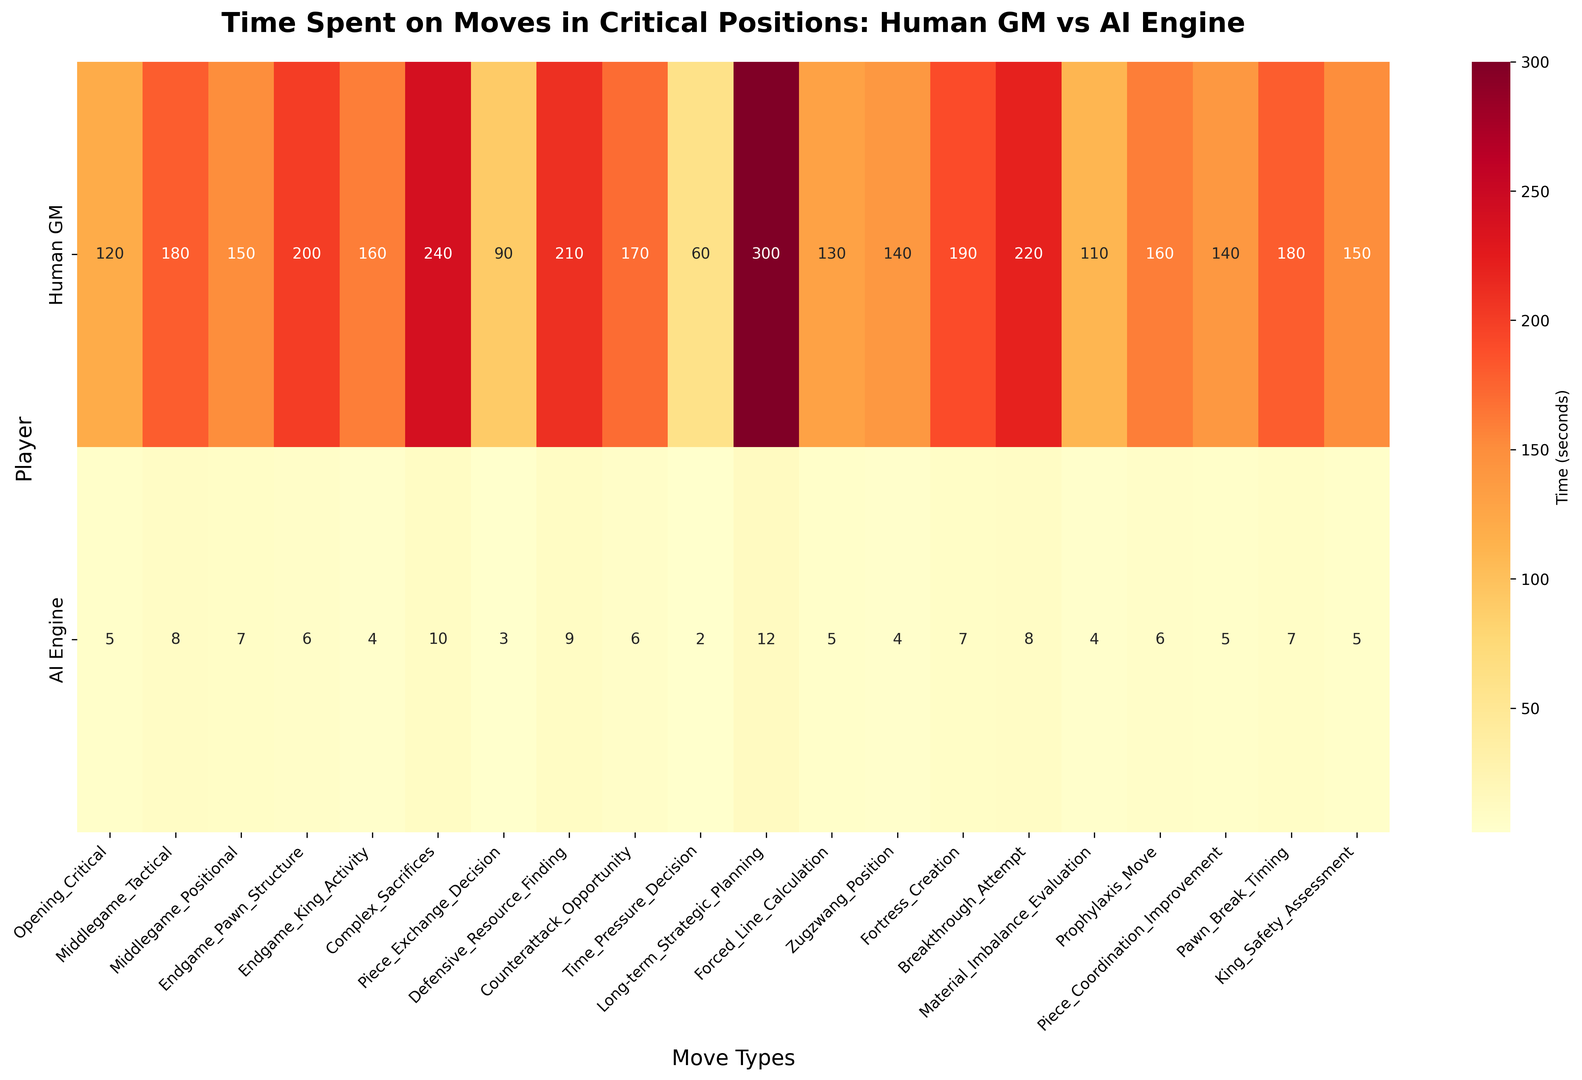What is the move type where human grandmasters spend the most time? The highest value for human grandmasters is observed by looking at the colors and values, which peak at 300 seconds. This occurs at the 'Long-term_Strategic_Planning' move type.
Answer: 'Long-term_Strategic_Planning' Which move type has the smallest difference in time spent between human grandmasters and AI engines? Calculate the difference in time for each move type, and compare them. The smallest difference is for 'Piece_Exchange_Decision', with a difference of 87 seconds (90 - 3).
Answer: 'Piece_Exchange_Decision' What is the average time spent by AI engines across all moves? Sum all the AI time values: (5 + 8 + 7 + 6 + 4 + 10 + 3 + 9 + 6 + 2 + 12 + 5 + 4 + 7 + 8 + 4 + 6 + 5 + 7 + 5) = 113. Then, divide by the number of move types (20): 113 / 20 = 5.65. The average is approximately 5.65 seconds.
Answer: 5.65 seconds Which move type shows the greatest disparity in time spent between human grandmasters and AI engines? Calculate the absolute difference between human and AI time for each move type and identify the largest. The greatest disparity is for 'Long-term_Strategic_Planning' with a difference of 288 seconds (300 - 12).
Answer: 'Long-term_Strategic_Planning' Is there any move type where AI engines and human grandmasters spend equal time? Examine the times for both human grandmasters and AI engines for each move type to check if any values match. There are no move types where the time is equal.
Answer: No How does the time spent by AI engines on 'Forced_Line_Calculation' compare to the time human grandmasters spend on 'Defensive_Resource_Finding'? AI engines spend 5 seconds on 'Forced_Line_Calculation', while human grandmasters spend 210 seconds on 'Defensive_Resource_Finding'. Comparing these, AI engines spend significantly less time.
Answer: AI engines spend significantly less time Which three move types have human grandmasters spending the least amount of time? Identify and rank the three smallest values for human grandmasters. They are 'Piece_Exchange_Decision' (90 seconds), 'Time_Pressure_Decision' (60 seconds), and 'Material_Imbalance_Evaluation' (110 seconds).
Answer: 'Piece_Exchange_Decision', 'Time_Pressure_Decision', 'Material_Imbalance_Evaluation' For the move type 'Complex_Sacrifices', how much more time do human grandmasters spend compared to AI engines? The time for human grandmasters is 240 seconds and for AI engines is 10 seconds. The difference is 240 - 10 = 230 seconds.
Answer: 230 seconds 